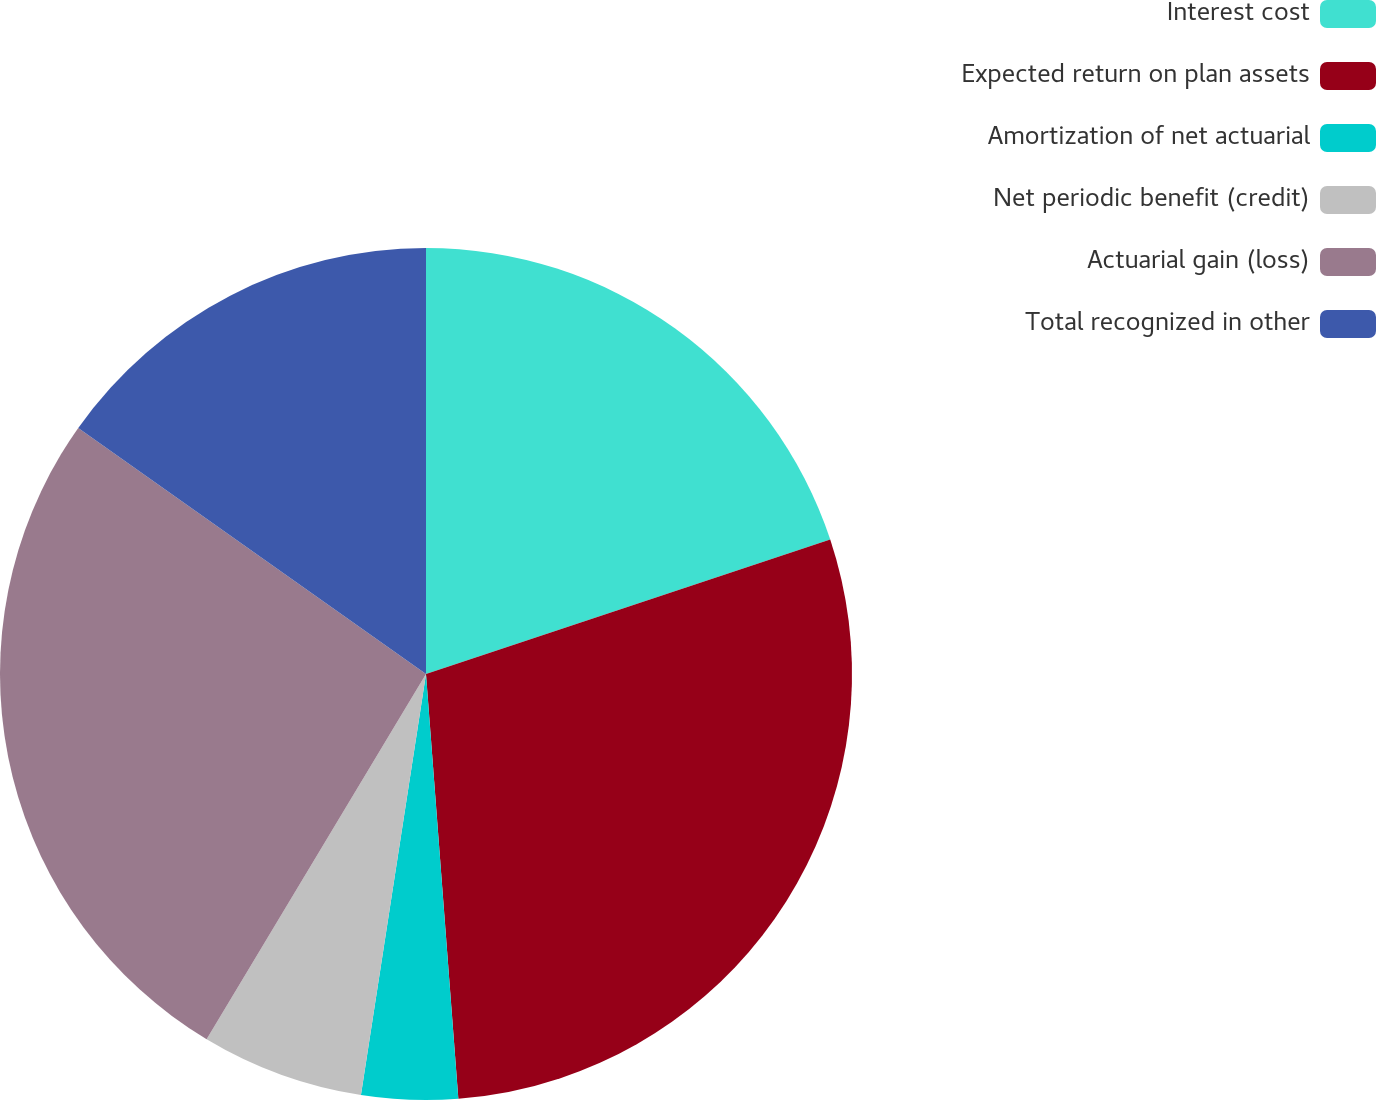Convert chart. <chart><loc_0><loc_0><loc_500><loc_500><pie_chart><fcel>Interest cost<fcel>Expected return on plan assets<fcel>Amortization of net actuarial<fcel>Net periodic benefit (credit)<fcel>Actuarial gain (loss)<fcel>Total recognized in other<nl><fcel>19.89%<fcel>28.9%<fcel>3.65%<fcel>6.17%<fcel>26.19%<fcel>15.2%<nl></chart> 